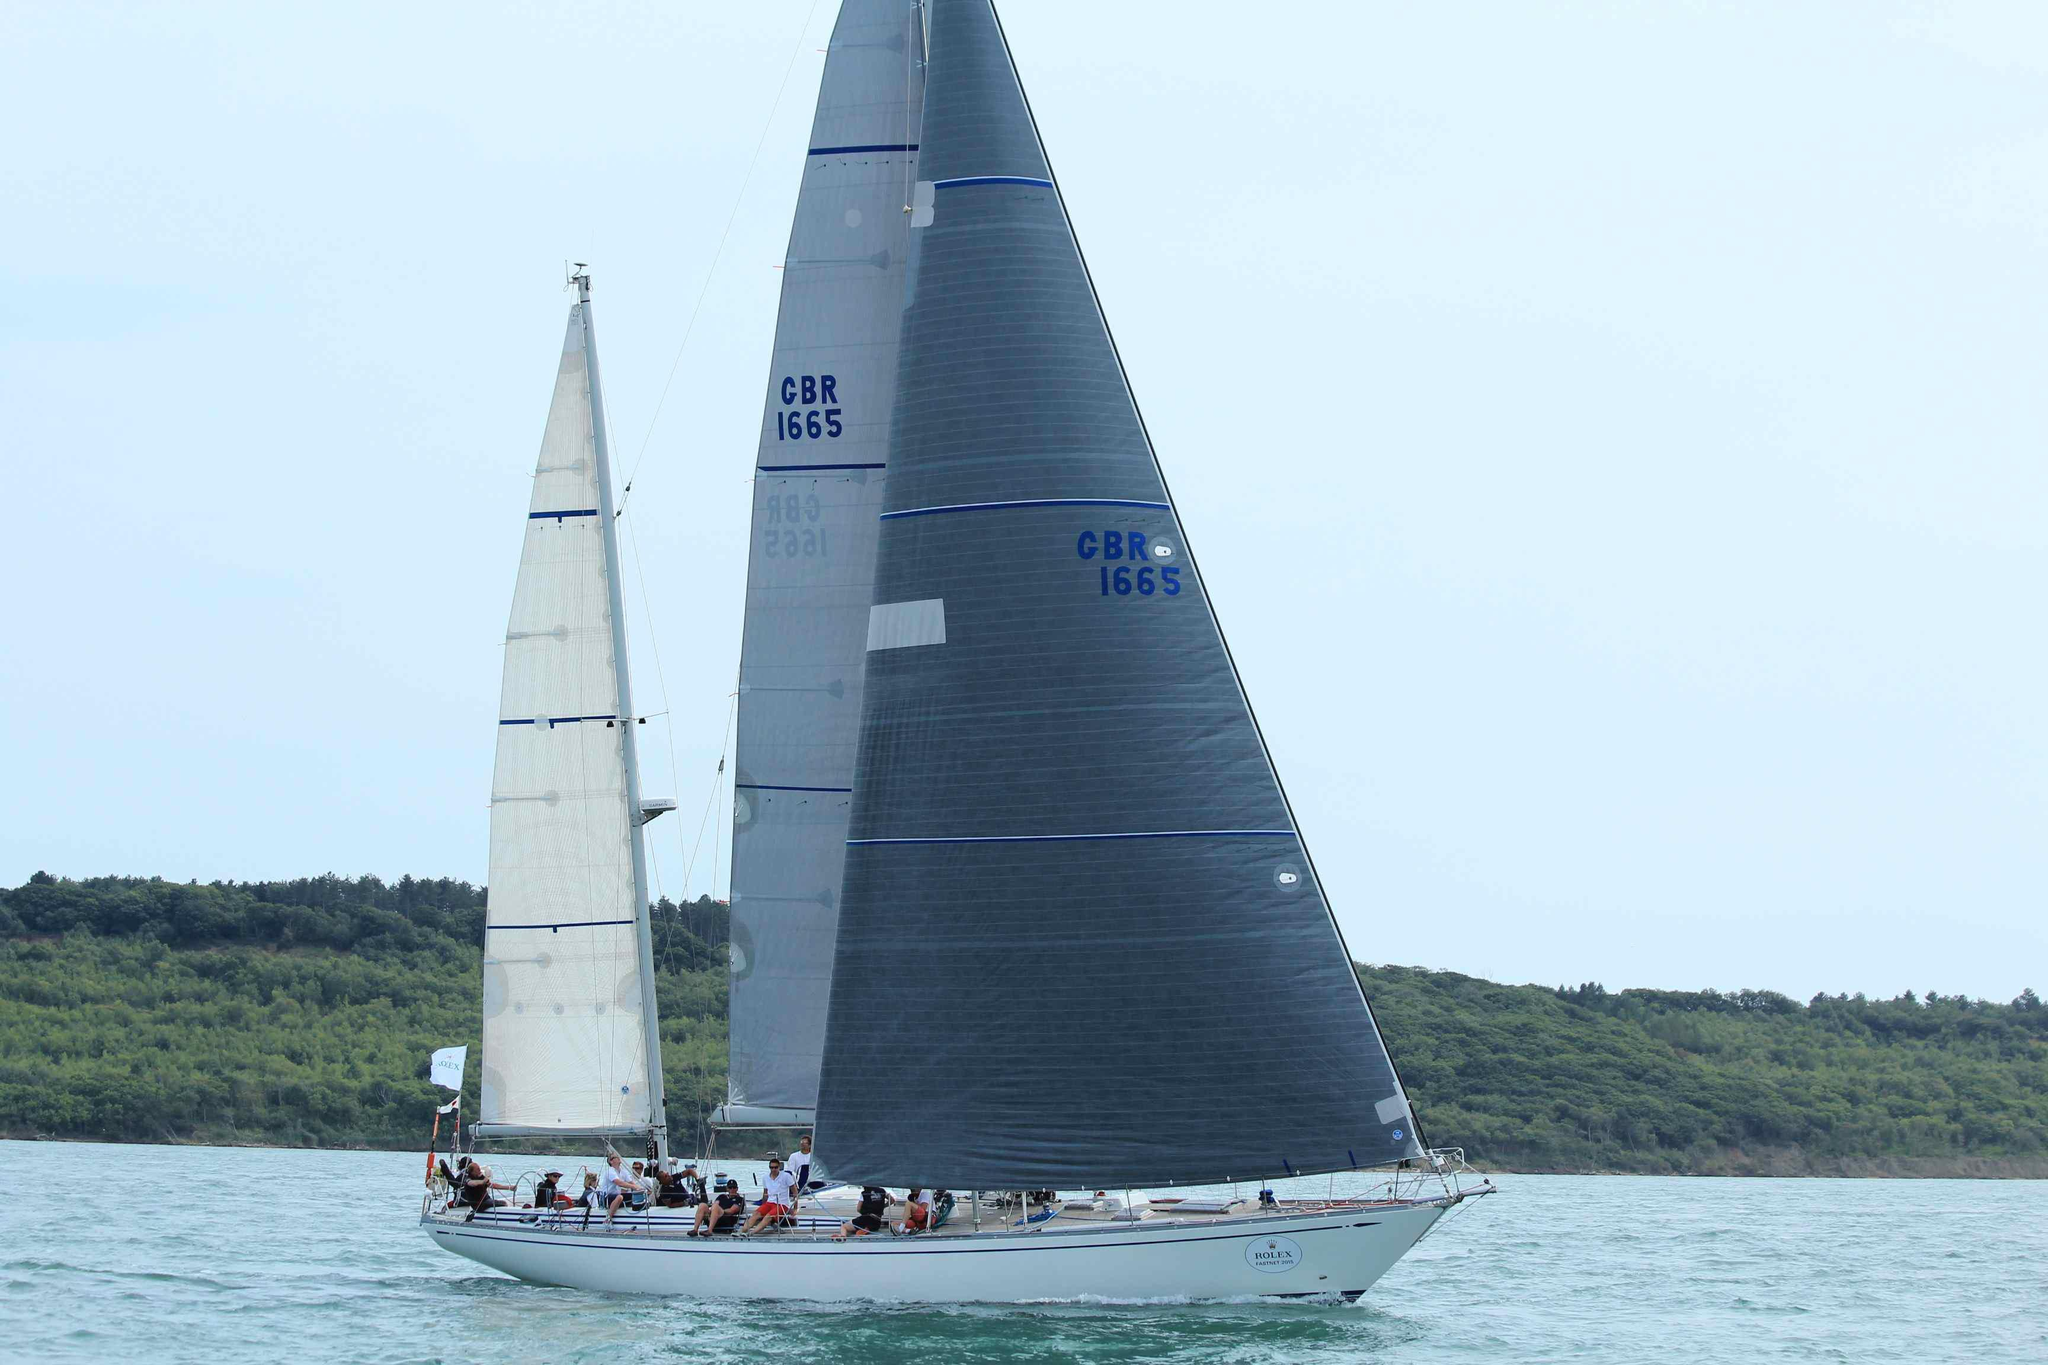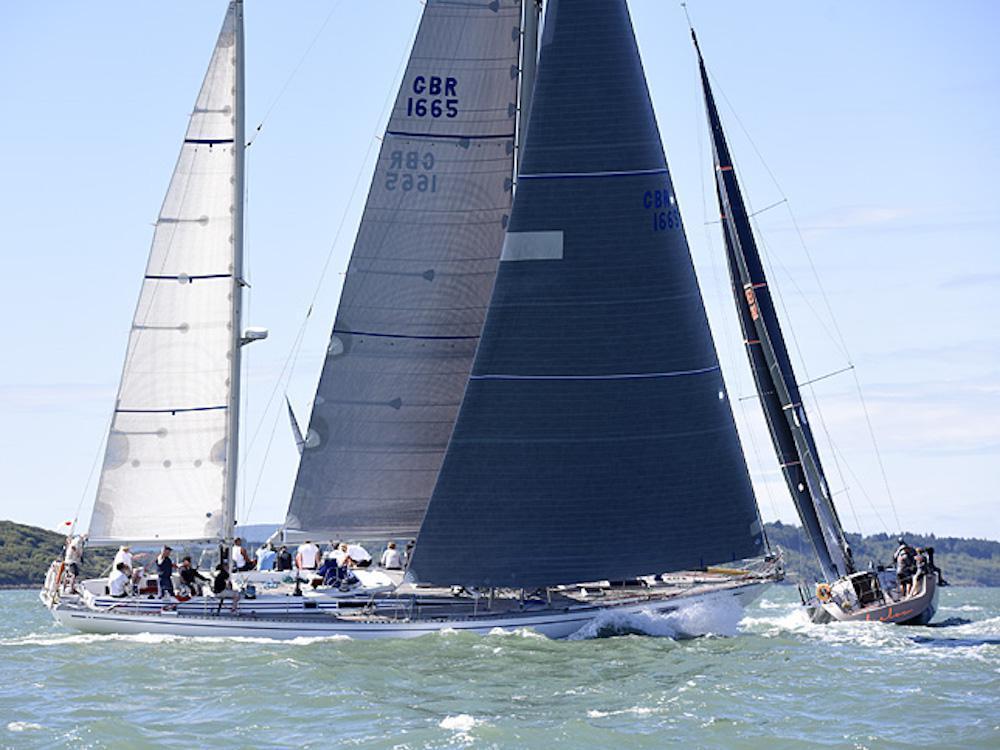The first image is the image on the left, the second image is the image on the right. Given the left and right images, does the statement "An image shows multiple sailboats with unfurled sails." hold true? Answer yes or no. Yes. The first image is the image on the left, the second image is the image on the right. Considering the images on both sides, is "There are more boats in the image on the right than the image on the left." valid? Answer yes or no. Yes. 